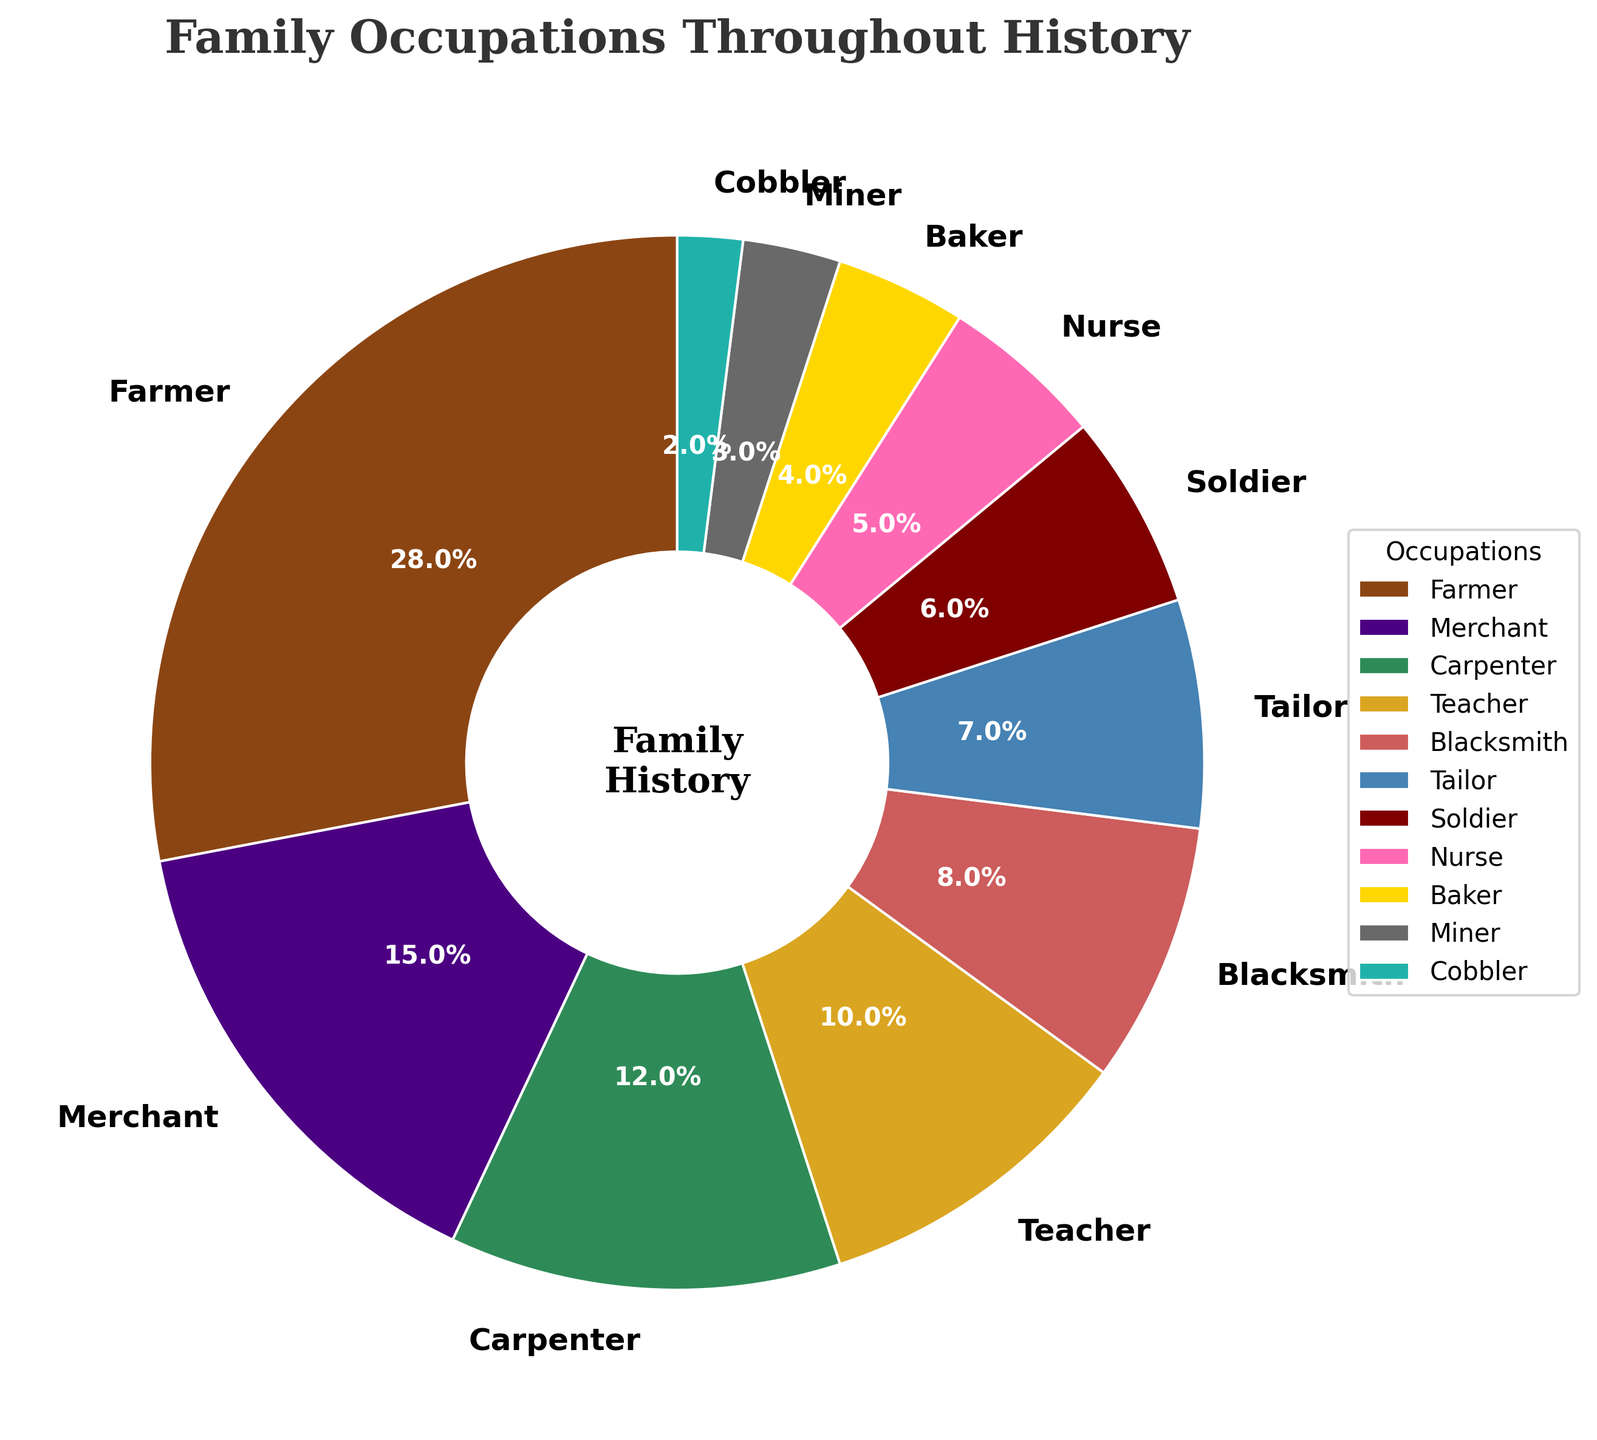What occupation has the highest proportion in the pie chart? The occupation with the highest visual representation on the pie chart is the one occupying the largest segment. From the data, Farmer has the highest percentage at 28%.
Answer: Farmer Which two occupations combined make up more than 40% of the pie chart? To find two occupations that combined make up more than 40%, we need to identify pairs from the data. Farmer (28%) and Merchant (15%) combined give 43%.
Answer: Farmer and Merchant How does the percentage of Carpenters compare to that of Blacksmiths? From the data, Carpenters hold 12% and Blacksmiths 8%. Carpenters have a larger portion compared to Blacksmiths.
Answer: Carpenters have more percentage than Blacksmiths What is the total percentage of all healthcare-related occupations in the chart? From the data, Nurse is the only healthcare-related occupation with a percentage of 5%. Sum it up: 5%.
Answer: 5% Which occupation appears the least in the pie chart, and what percentage does it represent? The smallest segment visually, representing the least proportion, is Cobblers with 2%.
Answer: Cobbler, 2% By how much does the percentage of Farmers exceed that of Teachers? Farmers have 28% and Teachers have 10%. Subtracting these gives 28% - 10% = 18%.
Answer: 18% What is the combined percentage of Farmer, Merchant, and Carpenter occupations? Summing the percentages of Farmer (28%), Merchant (15%), and Carpenter (12%) gives 28% + 15% + 12% = 55%.
Answer: 55% If you add the percentages of Soldier and Tailor, which other single occupation has a similar combined percentage? Soldier is 6% and Tailor is 7%. Their combined percentage is 6% + 7% = 13%. The closest single occupation is Merchant with 15%.
Answer: Merchant What is the difference in percentage between the occupation with the highest proportion and the one with the lowest? The highest is Farmer at 28% and the lowest is Cobbler at 2%. Difference is 28% - 2% = 26%.
Answer: 26% 